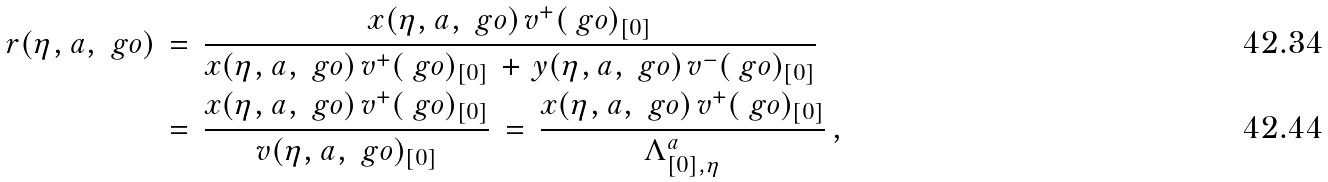Convert formula to latex. <formula><loc_0><loc_0><loc_500><loc_500>r ( \eta , a , \ g o ) & \, = \, \frac { x ( \eta , a , \ g o ) \, v ^ { + } ( \ g o ) _ { [ 0 ] } } { x ( \eta , a , \ g o ) \, v ^ { + } ( \ g o ) _ { [ 0 ] } \, + \, y ( \eta , a , \ g o ) \, v ^ { - } ( \ g o ) _ { [ 0 ] } } \\ & \, = \, \frac { x ( \eta , a , \ g o ) \, v ^ { + } ( \ g o ) _ { [ 0 ] } } { v ( \eta , a , \ g o ) _ { [ 0 ] } } \, = \, \frac { x ( \eta , a , \ g o ) \, v ^ { + } ( \ g o ) _ { [ 0 ] } } { \Lambda ^ { a } _ { [ 0 ] , \eta } } \, ,</formula> 